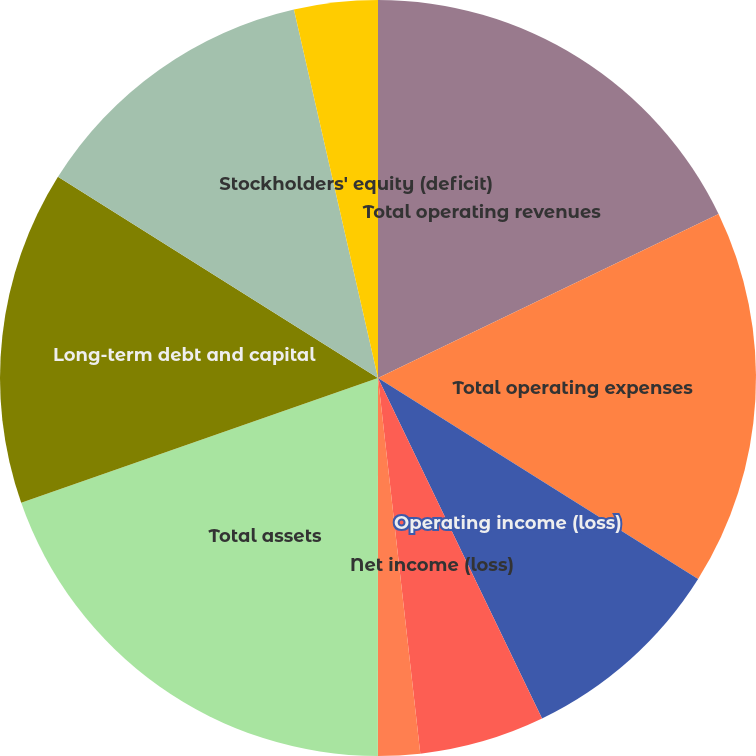Convert chart. <chart><loc_0><loc_0><loc_500><loc_500><pie_chart><fcel>Total operating revenues<fcel>Total operating expenses<fcel>Operating income (loss)<fcel>Net income (loss)<fcel>Basic<fcel>Diluted<fcel>Total assets<fcel>Long-term debt and capital<fcel>Pension and postretirement<fcel>Stockholders' equity (deficit)<nl><fcel>17.86%<fcel>16.07%<fcel>8.93%<fcel>5.36%<fcel>1.79%<fcel>0.0%<fcel>19.64%<fcel>14.29%<fcel>12.5%<fcel>3.57%<nl></chart> 